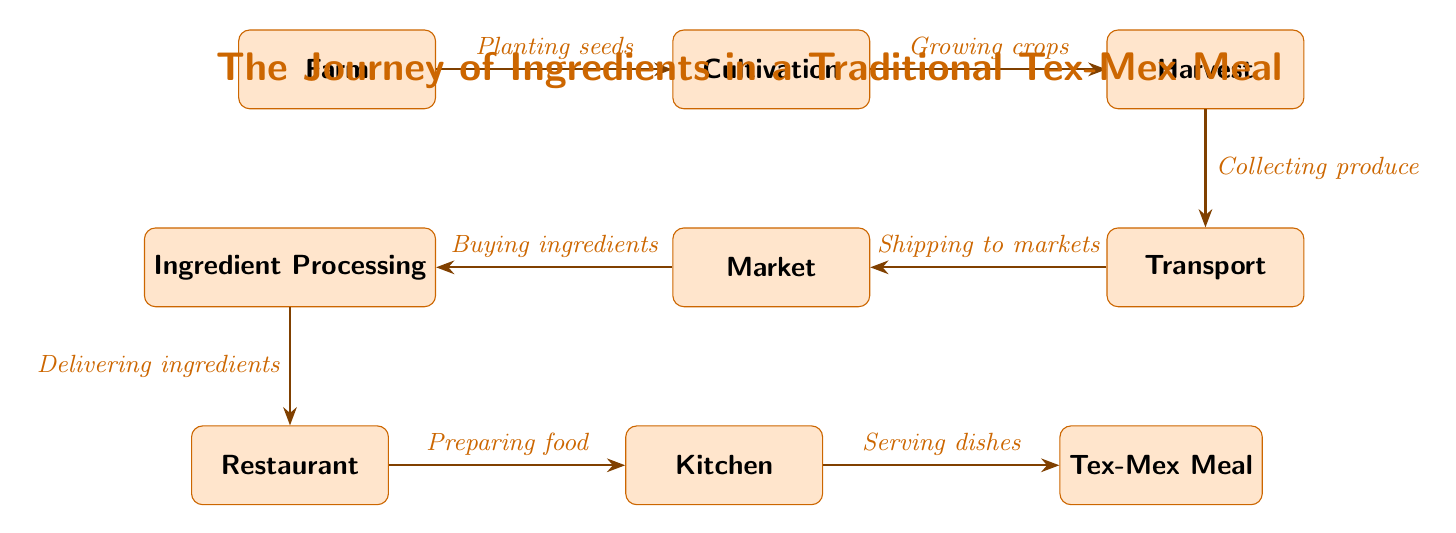What is the first step in the food chain? The first step in the food chain is represented by the node labeled "Farm," which indicates the starting point of the ingredient journey.
Answer: Farm How many nodes are there in the food chain? By counting each of the labeled nodes in the diagram, we find a total of 8 nodes representing different stages in the food chain.
Answer: 8 What do we do after harvesting the crops? After harvesting, the next step represented in the diagram is "Transport," showing that collected produce is shipped to various locations.
Answer: Transport Which node comes after the "Market"? According to the flow in the diagram, the node that follows "Market" is "Ingredient Processing," indicating the next stage after purchasing ingredients.
Answer: Ingredient Processing What label describes the action between "Cultivation" and "Harvest"? The label connecting "Cultivation" to "Harvest" describes the process as "Growing crops," which highlights the key activity performed during this stage.
Answer: Growing crops Which node represents the final outcome of the food chain? The last node, at the end of the food chain, is "Tex-Mex Meal," which signifies the completed dish that results from the entire process.
Answer: Tex-Mex Meal At which point do we prepare the food? Food preparation occurs in the node labeled "Kitchen," which is where the ingredients are utilized to make the dishes after they have been delivered.
Answer: Kitchen What action occurs between "Processing" and "Restaurant"? The diagram shows that the action between "Processing" and "Restaurant" is labeled "Delivering ingredients," indicating what happens next in the ingredient journey.
Answer: Delivering ingredients What step occurs between "Transport" and "Market"? The flow from "Transport" to "Market" is marked with the label "Shipping to markets," detailing the process of moving produce to selling locations.
Answer: Shipping to markets 